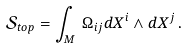Convert formula to latex. <formula><loc_0><loc_0><loc_500><loc_500>\mathcal { S } _ { t o p } = \int _ { M } \, \Omega _ { i j } d X ^ { i } \wedge d X ^ { j } \, .</formula> 